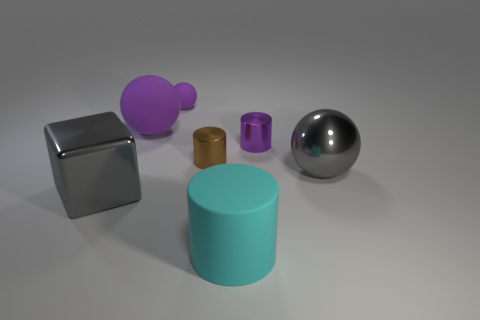Is the tiny matte object the same color as the large matte ball?
Make the answer very short. Yes. There is a small brown object; is its shape the same as the small purple object right of the cyan thing?
Make the answer very short. Yes. What number of other objects are the same material as the cyan object?
Make the answer very short. 2. Are there any tiny cylinders on the right side of the big cyan matte thing?
Make the answer very short. Yes. There is a purple metal cylinder; is its size the same as the gray object on the right side of the matte cylinder?
Ensure brevity in your answer.  No. There is a big metallic object in front of the gray metallic object right of the gray shiny block; what is its color?
Offer a very short reply. Gray. Is the size of the brown thing the same as the purple metal thing?
Provide a succinct answer. Yes. There is a rubber thing that is to the right of the large matte ball and to the left of the tiny brown metallic object; what color is it?
Provide a short and direct response. Purple. What size is the gray metallic ball?
Your response must be concise. Large. There is a big thing behind the tiny brown metal cylinder; is its color the same as the cube?
Offer a terse response. No. 